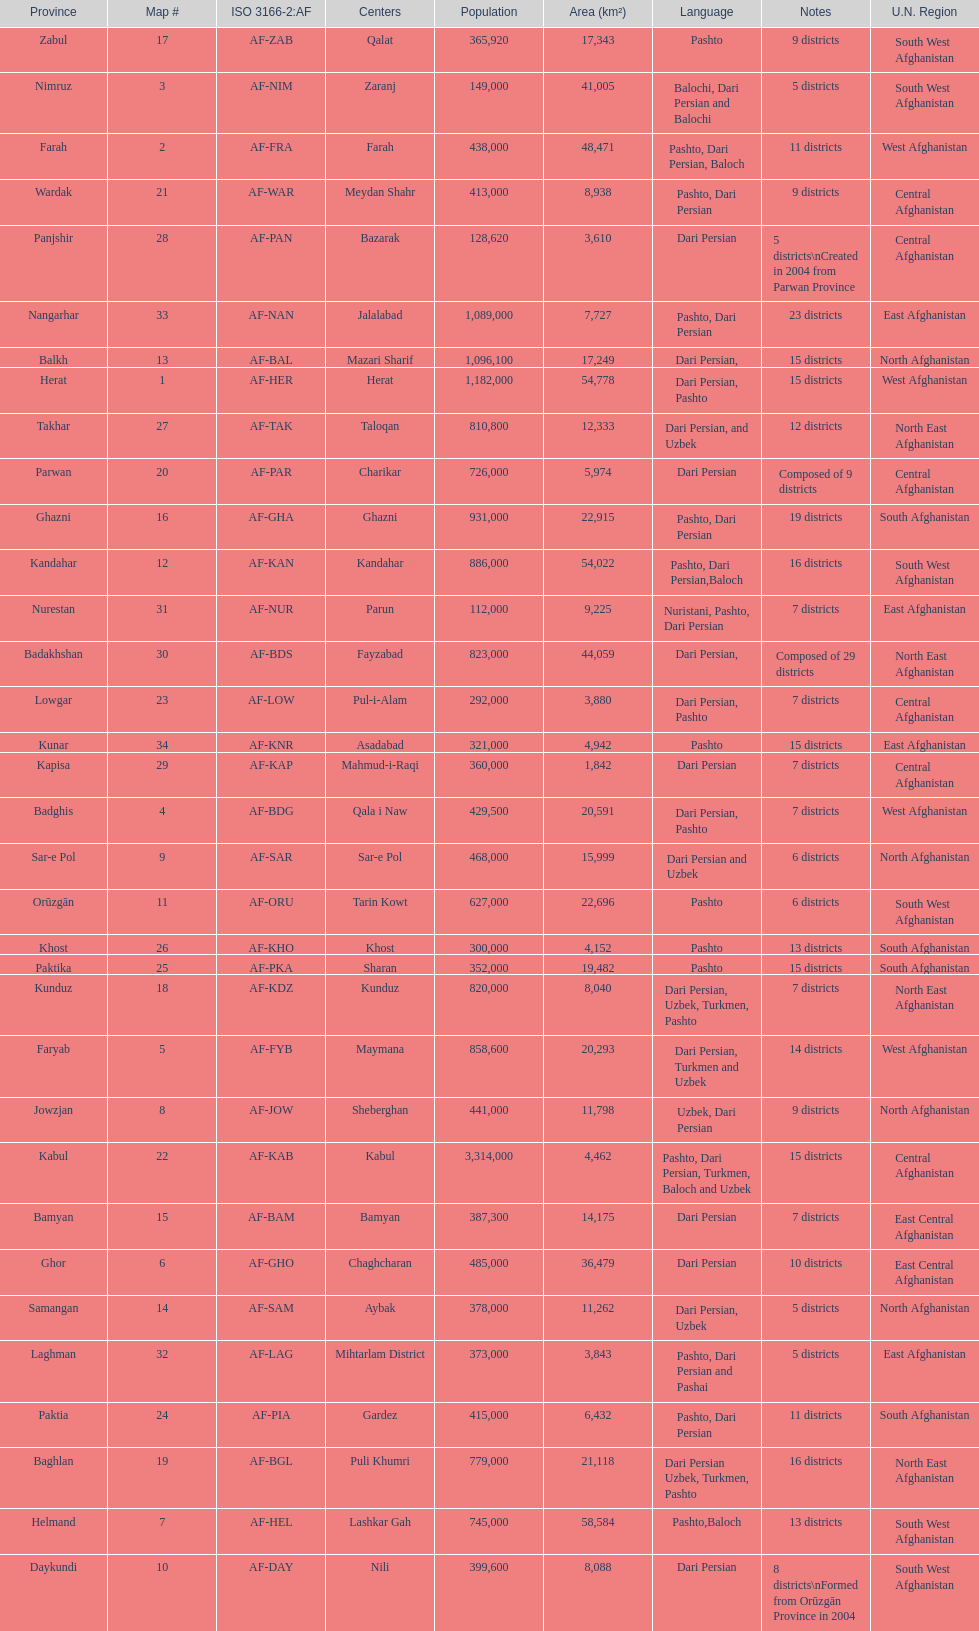How many provinces have pashto as one of their languages 20. 